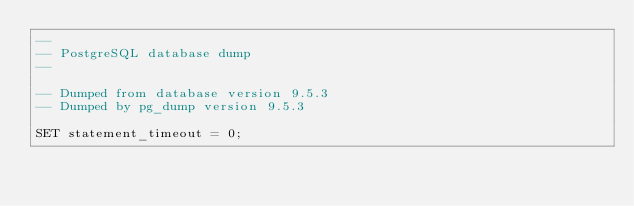Convert code to text. <code><loc_0><loc_0><loc_500><loc_500><_SQL_>--
-- PostgreSQL database dump
--

-- Dumped from database version 9.5.3
-- Dumped by pg_dump version 9.5.3

SET statement_timeout = 0;</code> 